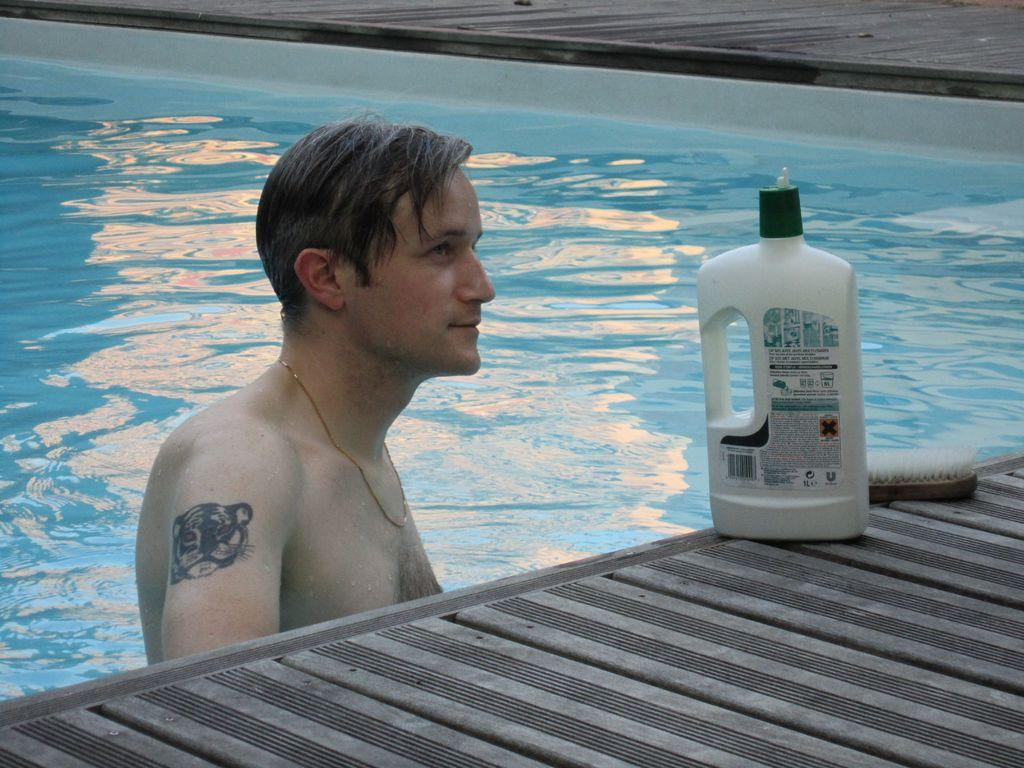What is the man in the image doing? The man is in a swimming pool. What objects can be seen on the right side of the image? There is a bottle and a brush on the right side of the image. Both the bottle and brush are placed on the floor. What type of lace can be seen on the man's swimsuit in the image? There is no lace visible on the man's swimsuit in the image. Is the man in the swimming pool being held in a jail cell? No, the man in the swimming pool is not in a jail cell; he is swimming in a pool. 